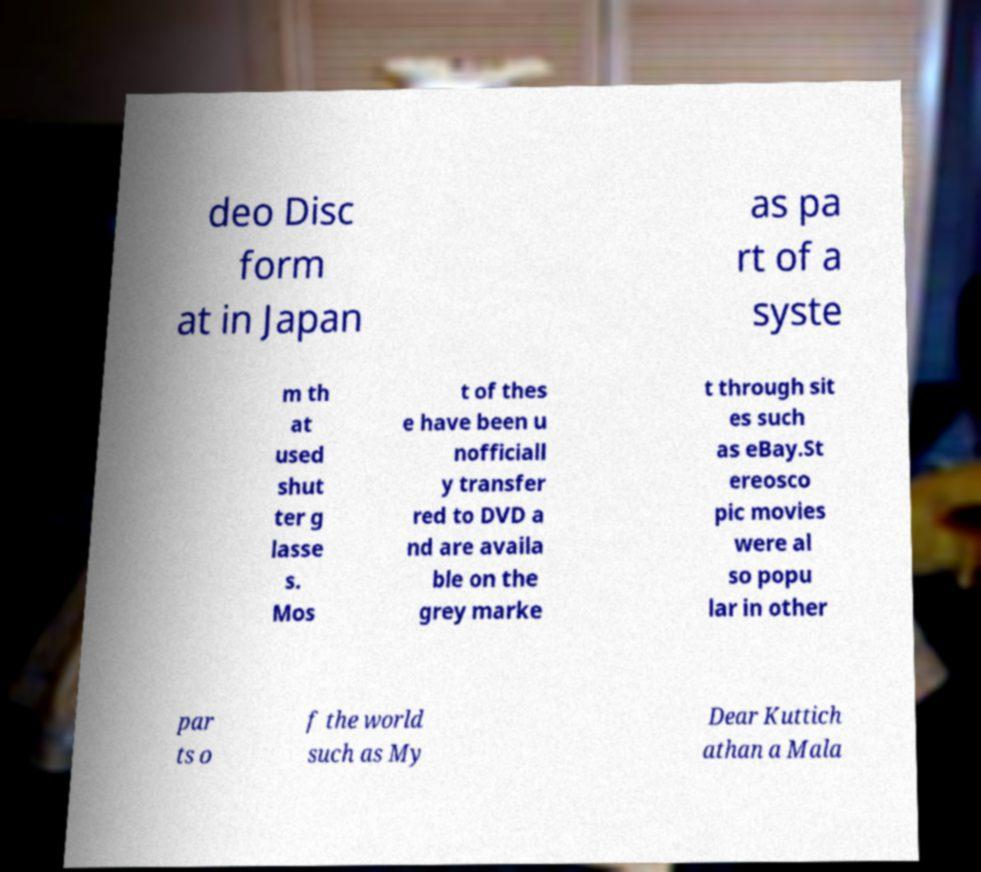What messages or text are displayed in this image? I need them in a readable, typed format. deo Disc form at in Japan as pa rt of a syste m th at used shut ter g lasse s. Mos t of thes e have been u nofficiall y transfer red to DVD a nd are availa ble on the grey marke t through sit es such as eBay.St ereosco pic movies were al so popu lar in other par ts o f the world such as My Dear Kuttich athan a Mala 